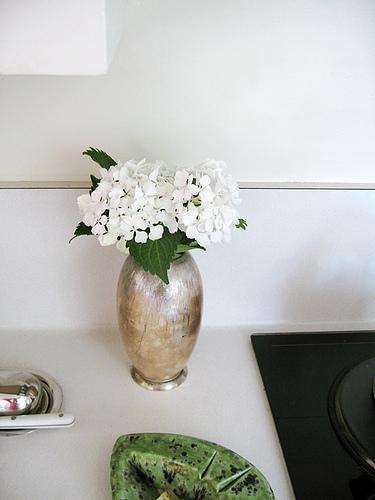How many vases are in the photo?
Give a very brief answer. 1. 